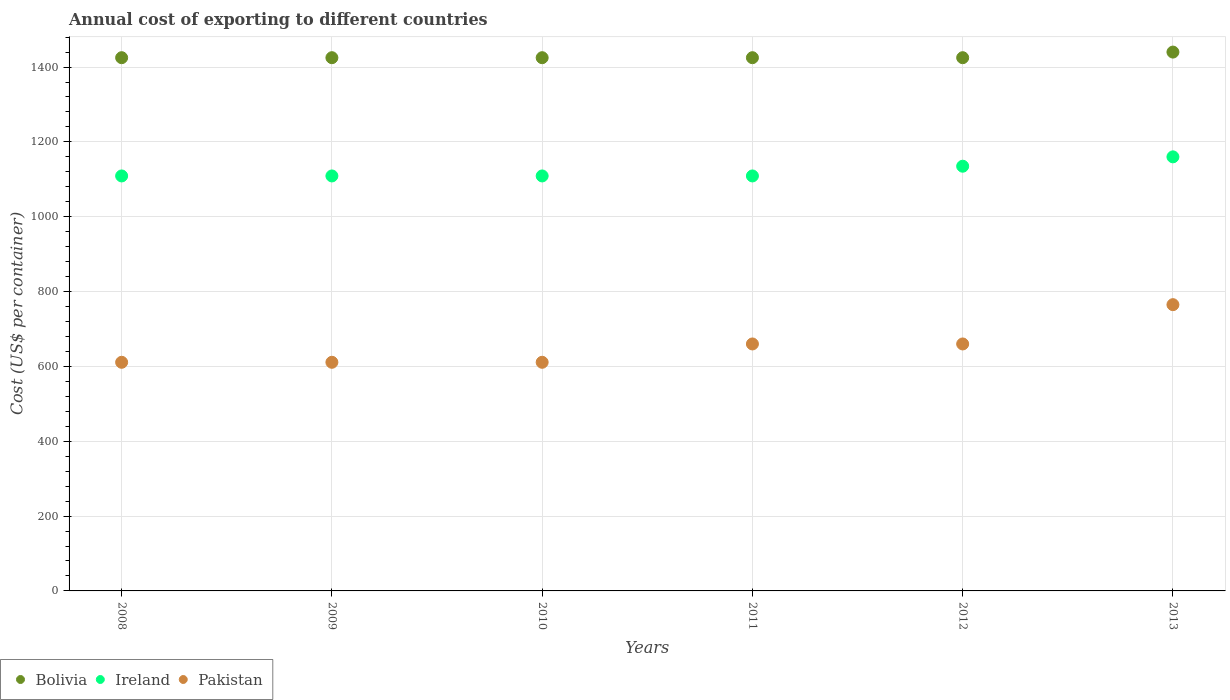What is the total annual cost of exporting in Bolivia in 2013?
Make the answer very short. 1440. Across all years, what is the maximum total annual cost of exporting in Pakistan?
Give a very brief answer. 765. Across all years, what is the minimum total annual cost of exporting in Pakistan?
Give a very brief answer. 611. In which year was the total annual cost of exporting in Pakistan maximum?
Keep it short and to the point. 2013. What is the total total annual cost of exporting in Bolivia in the graph?
Provide a succinct answer. 8565. What is the difference between the total annual cost of exporting in Ireland in 2010 and that in 2012?
Your response must be concise. -26. What is the difference between the total annual cost of exporting in Bolivia in 2013 and the total annual cost of exporting in Pakistan in 2012?
Give a very brief answer. 780. What is the average total annual cost of exporting in Bolivia per year?
Provide a short and direct response. 1427.5. In the year 2008, what is the difference between the total annual cost of exporting in Ireland and total annual cost of exporting in Bolivia?
Provide a short and direct response. -316. In how many years, is the total annual cost of exporting in Bolivia greater than 880 US$?
Provide a succinct answer. 6. What is the ratio of the total annual cost of exporting in Ireland in 2008 to that in 2010?
Keep it short and to the point. 1. What is the difference between the highest and the second highest total annual cost of exporting in Pakistan?
Make the answer very short. 105. What is the difference between the highest and the lowest total annual cost of exporting in Pakistan?
Provide a succinct answer. 154. In how many years, is the total annual cost of exporting in Ireland greater than the average total annual cost of exporting in Ireland taken over all years?
Provide a short and direct response. 2. Is the sum of the total annual cost of exporting in Pakistan in 2010 and 2011 greater than the maximum total annual cost of exporting in Ireland across all years?
Provide a short and direct response. Yes. Does the total annual cost of exporting in Pakistan monotonically increase over the years?
Make the answer very short. No. Is the total annual cost of exporting in Ireland strictly less than the total annual cost of exporting in Pakistan over the years?
Your answer should be compact. No. How many years are there in the graph?
Give a very brief answer. 6. Does the graph contain grids?
Give a very brief answer. Yes. Where does the legend appear in the graph?
Ensure brevity in your answer.  Bottom left. How many legend labels are there?
Offer a very short reply. 3. How are the legend labels stacked?
Ensure brevity in your answer.  Horizontal. What is the title of the graph?
Provide a succinct answer. Annual cost of exporting to different countries. What is the label or title of the Y-axis?
Offer a very short reply. Cost (US$ per container). What is the Cost (US$ per container) in Bolivia in 2008?
Provide a succinct answer. 1425. What is the Cost (US$ per container) in Ireland in 2008?
Provide a succinct answer. 1109. What is the Cost (US$ per container) of Pakistan in 2008?
Keep it short and to the point. 611. What is the Cost (US$ per container) of Bolivia in 2009?
Give a very brief answer. 1425. What is the Cost (US$ per container) in Ireland in 2009?
Offer a very short reply. 1109. What is the Cost (US$ per container) in Pakistan in 2009?
Give a very brief answer. 611. What is the Cost (US$ per container) in Bolivia in 2010?
Your answer should be compact. 1425. What is the Cost (US$ per container) of Ireland in 2010?
Your answer should be very brief. 1109. What is the Cost (US$ per container) of Pakistan in 2010?
Your answer should be compact. 611. What is the Cost (US$ per container) in Bolivia in 2011?
Your response must be concise. 1425. What is the Cost (US$ per container) in Ireland in 2011?
Offer a very short reply. 1109. What is the Cost (US$ per container) of Pakistan in 2011?
Your answer should be compact. 660. What is the Cost (US$ per container) of Bolivia in 2012?
Keep it short and to the point. 1425. What is the Cost (US$ per container) in Ireland in 2012?
Your response must be concise. 1135. What is the Cost (US$ per container) in Pakistan in 2012?
Make the answer very short. 660. What is the Cost (US$ per container) in Bolivia in 2013?
Offer a terse response. 1440. What is the Cost (US$ per container) in Ireland in 2013?
Your response must be concise. 1160. What is the Cost (US$ per container) in Pakistan in 2013?
Your response must be concise. 765. Across all years, what is the maximum Cost (US$ per container) in Bolivia?
Your answer should be very brief. 1440. Across all years, what is the maximum Cost (US$ per container) in Ireland?
Your answer should be very brief. 1160. Across all years, what is the maximum Cost (US$ per container) of Pakistan?
Your answer should be compact. 765. Across all years, what is the minimum Cost (US$ per container) in Bolivia?
Your response must be concise. 1425. Across all years, what is the minimum Cost (US$ per container) in Ireland?
Give a very brief answer. 1109. Across all years, what is the minimum Cost (US$ per container) of Pakistan?
Give a very brief answer. 611. What is the total Cost (US$ per container) in Bolivia in the graph?
Your answer should be very brief. 8565. What is the total Cost (US$ per container) in Ireland in the graph?
Your answer should be very brief. 6731. What is the total Cost (US$ per container) in Pakistan in the graph?
Your answer should be compact. 3918. What is the difference between the Cost (US$ per container) of Bolivia in 2008 and that in 2009?
Your response must be concise. 0. What is the difference between the Cost (US$ per container) in Ireland in 2008 and that in 2009?
Your answer should be compact. 0. What is the difference between the Cost (US$ per container) of Ireland in 2008 and that in 2010?
Give a very brief answer. 0. What is the difference between the Cost (US$ per container) in Pakistan in 2008 and that in 2010?
Your answer should be very brief. 0. What is the difference between the Cost (US$ per container) in Bolivia in 2008 and that in 2011?
Make the answer very short. 0. What is the difference between the Cost (US$ per container) in Ireland in 2008 and that in 2011?
Your answer should be compact. 0. What is the difference between the Cost (US$ per container) of Pakistan in 2008 and that in 2011?
Keep it short and to the point. -49. What is the difference between the Cost (US$ per container) in Bolivia in 2008 and that in 2012?
Make the answer very short. 0. What is the difference between the Cost (US$ per container) in Pakistan in 2008 and that in 2012?
Give a very brief answer. -49. What is the difference between the Cost (US$ per container) of Bolivia in 2008 and that in 2013?
Give a very brief answer. -15. What is the difference between the Cost (US$ per container) in Ireland in 2008 and that in 2013?
Provide a succinct answer. -51. What is the difference between the Cost (US$ per container) in Pakistan in 2008 and that in 2013?
Make the answer very short. -154. What is the difference between the Cost (US$ per container) in Bolivia in 2009 and that in 2010?
Offer a terse response. 0. What is the difference between the Cost (US$ per container) of Ireland in 2009 and that in 2010?
Keep it short and to the point. 0. What is the difference between the Cost (US$ per container) of Pakistan in 2009 and that in 2010?
Your response must be concise. 0. What is the difference between the Cost (US$ per container) in Bolivia in 2009 and that in 2011?
Your response must be concise. 0. What is the difference between the Cost (US$ per container) in Pakistan in 2009 and that in 2011?
Offer a very short reply. -49. What is the difference between the Cost (US$ per container) of Ireland in 2009 and that in 2012?
Offer a very short reply. -26. What is the difference between the Cost (US$ per container) of Pakistan in 2009 and that in 2012?
Provide a succinct answer. -49. What is the difference between the Cost (US$ per container) in Bolivia in 2009 and that in 2013?
Offer a terse response. -15. What is the difference between the Cost (US$ per container) of Ireland in 2009 and that in 2013?
Give a very brief answer. -51. What is the difference between the Cost (US$ per container) of Pakistan in 2009 and that in 2013?
Give a very brief answer. -154. What is the difference between the Cost (US$ per container) in Bolivia in 2010 and that in 2011?
Ensure brevity in your answer.  0. What is the difference between the Cost (US$ per container) in Pakistan in 2010 and that in 2011?
Keep it short and to the point. -49. What is the difference between the Cost (US$ per container) of Ireland in 2010 and that in 2012?
Provide a succinct answer. -26. What is the difference between the Cost (US$ per container) of Pakistan in 2010 and that in 2012?
Your answer should be very brief. -49. What is the difference between the Cost (US$ per container) of Ireland in 2010 and that in 2013?
Provide a short and direct response. -51. What is the difference between the Cost (US$ per container) of Pakistan in 2010 and that in 2013?
Offer a terse response. -154. What is the difference between the Cost (US$ per container) of Bolivia in 2011 and that in 2012?
Offer a very short reply. 0. What is the difference between the Cost (US$ per container) of Ireland in 2011 and that in 2012?
Your response must be concise. -26. What is the difference between the Cost (US$ per container) of Ireland in 2011 and that in 2013?
Make the answer very short. -51. What is the difference between the Cost (US$ per container) of Pakistan in 2011 and that in 2013?
Make the answer very short. -105. What is the difference between the Cost (US$ per container) of Bolivia in 2012 and that in 2013?
Provide a short and direct response. -15. What is the difference between the Cost (US$ per container) in Ireland in 2012 and that in 2013?
Keep it short and to the point. -25. What is the difference between the Cost (US$ per container) in Pakistan in 2012 and that in 2013?
Your answer should be very brief. -105. What is the difference between the Cost (US$ per container) of Bolivia in 2008 and the Cost (US$ per container) of Ireland in 2009?
Provide a succinct answer. 316. What is the difference between the Cost (US$ per container) in Bolivia in 2008 and the Cost (US$ per container) in Pakistan in 2009?
Your response must be concise. 814. What is the difference between the Cost (US$ per container) of Ireland in 2008 and the Cost (US$ per container) of Pakistan in 2009?
Your response must be concise. 498. What is the difference between the Cost (US$ per container) of Bolivia in 2008 and the Cost (US$ per container) of Ireland in 2010?
Give a very brief answer. 316. What is the difference between the Cost (US$ per container) in Bolivia in 2008 and the Cost (US$ per container) in Pakistan in 2010?
Keep it short and to the point. 814. What is the difference between the Cost (US$ per container) of Ireland in 2008 and the Cost (US$ per container) of Pakistan in 2010?
Make the answer very short. 498. What is the difference between the Cost (US$ per container) of Bolivia in 2008 and the Cost (US$ per container) of Ireland in 2011?
Provide a short and direct response. 316. What is the difference between the Cost (US$ per container) in Bolivia in 2008 and the Cost (US$ per container) in Pakistan in 2011?
Your response must be concise. 765. What is the difference between the Cost (US$ per container) in Ireland in 2008 and the Cost (US$ per container) in Pakistan in 2011?
Your answer should be very brief. 449. What is the difference between the Cost (US$ per container) in Bolivia in 2008 and the Cost (US$ per container) in Ireland in 2012?
Offer a terse response. 290. What is the difference between the Cost (US$ per container) of Bolivia in 2008 and the Cost (US$ per container) of Pakistan in 2012?
Your answer should be compact. 765. What is the difference between the Cost (US$ per container) of Ireland in 2008 and the Cost (US$ per container) of Pakistan in 2012?
Give a very brief answer. 449. What is the difference between the Cost (US$ per container) in Bolivia in 2008 and the Cost (US$ per container) in Ireland in 2013?
Your response must be concise. 265. What is the difference between the Cost (US$ per container) in Bolivia in 2008 and the Cost (US$ per container) in Pakistan in 2013?
Ensure brevity in your answer.  660. What is the difference between the Cost (US$ per container) of Ireland in 2008 and the Cost (US$ per container) of Pakistan in 2013?
Provide a short and direct response. 344. What is the difference between the Cost (US$ per container) of Bolivia in 2009 and the Cost (US$ per container) of Ireland in 2010?
Give a very brief answer. 316. What is the difference between the Cost (US$ per container) of Bolivia in 2009 and the Cost (US$ per container) of Pakistan in 2010?
Your answer should be very brief. 814. What is the difference between the Cost (US$ per container) of Ireland in 2009 and the Cost (US$ per container) of Pakistan in 2010?
Give a very brief answer. 498. What is the difference between the Cost (US$ per container) in Bolivia in 2009 and the Cost (US$ per container) in Ireland in 2011?
Provide a succinct answer. 316. What is the difference between the Cost (US$ per container) in Bolivia in 2009 and the Cost (US$ per container) in Pakistan in 2011?
Provide a succinct answer. 765. What is the difference between the Cost (US$ per container) of Ireland in 2009 and the Cost (US$ per container) of Pakistan in 2011?
Your answer should be very brief. 449. What is the difference between the Cost (US$ per container) in Bolivia in 2009 and the Cost (US$ per container) in Ireland in 2012?
Provide a succinct answer. 290. What is the difference between the Cost (US$ per container) of Bolivia in 2009 and the Cost (US$ per container) of Pakistan in 2012?
Give a very brief answer. 765. What is the difference between the Cost (US$ per container) of Ireland in 2009 and the Cost (US$ per container) of Pakistan in 2012?
Provide a succinct answer. 449. What is the difference between the Cost (US$ per container) of Bolivia in 2009 and the Cost (US$ per container) of Ireland in 2013?
Offer a very short reply. 265. What is the difference between the Cost (US$ per container) of Bolivia in 2009 and the Cost (US$ per container) of Pakistan in 2013?
Offer a terse response. 660. What is the difference between the Cost (US$ per container) of Ireland in 2009 and the Cost (US$ per container) of Pakistan in 2013?
Offer a very short reply. 344. What is the difference between the Cost (US$ per container) of Bolivia in 2010 and the Cost (US$ per container) of Ireland in 2011?
Offer a terse response. 316. What is the difference between the Cost (US$ per container) in Bolivia in 2010 and the Cost (US$ per container) in Pakistan in 2011?
Your answer should be very brief. 765. What is the difference between the Cost (US$ per container) in Ireland in 2010 and the Cost (US$ per container) in Pakistan in 2011?
Give a very brief answer. 449. What is the difference between the Cost (US$ per container) in Bolivia in 2010 and the Cost (US$ per container) in Ireland in 2012?
Provide a succinct answer. 290. What is the difference between the Cost (US$ per container) of Bolivia in 2010 and the Cost (US$ per container) of Pakistan in 2012?
Provide a succinct answer. 765. What is the difference between the Cost (US$ per container) in Ireland in 2010 and the Cost (US$ per container) in Pakistan in 2012?
Your answer should be very brief. 449. What is the difference between the Cost (US$ per container) in Bolivia in 2010 and the Cost (US$ per container) in Ireland in 2013?
Your answer should be very brief. 265. What is the difference between the Cost (US$ per container) of Bolivia in 2010 and the Cost (US$ per container) of Pakistan in 2013?
Offer a very short reply. 660. What is the difference between the Cost (US$ per container) of Ireland in 2010 and the Cost (US$ per container) of Pakistan in 2013?
Your answer should be very brief. 344. What is the difference between the Cost (US$ per container) in Bolivia in 2011 and the Cost (US$ per container) in Ireland in 2012?
Your response must be concise. 290. What is the difference between the Cost (US$ per container) of Bolivia in 2011 and the Cost (US$ per container) of Pakistan in 2012?
Offer a terse response. 765. What is the difference between the Cost (US$ per container) in Ireland in 2011 and the Cost (US$ per container) in Pakistan in 2012?
Offer a terse response. 449. What is the difference between the Cost (US$ per container) of Bolivia in 2011 and the Cost (US$ per container) of Ireland in 2013?
Provide a short and direct response. 265. What is the difference between the Cost (US$ per container) of Bolivia in 2011 and the Cost (US$ per container) of Pakistan in 2013?
Your response must be concise. 660. What is the difference between the Cost (US$ per container) of Ireland in 2011 and the Cost (US$ per container) of Pakistan in 2013?
Your answer should be compact. 344. What is the difference between the Cost (US$ per container) of Bolivia in 2012 and the Cost (US$ per container) of Ireland in 2013?
Provide a succinct answer. 265. What is the difference between the Cost (US$ per container) in Bolivia in 2012 and the Cost (US$ per container) in Pakistan in 2013?
Offer a very short reply. 660. What is the difference between the Cost (US$ per container) in Ireland in 2012 and the Cost (US$ per container) in Pakistan in 2013?
Your answer should be very brief. 370. What is the average Cost (US$ per container) in Bolivia per year?
Offer a terse response. 1427.5. What is the average Cost (US$ per container) in Ireland per year?
Provide a short and direct response. 1121.83. What is the average Cost (US$ per container) in Pakistan per year?
Make the answer very short. 653. In the year 2008, what is the difference between the Cost (US$ per container) in Bolivia and Cost (US$ per container) in Ireland?
Provide a succinct answer. 316. In the year 2008, what is the difference between the Cost (US$ per container) of Bolivia and Cost (US$ per container) of Pakistan?
Make the answer very short. 814. In the year 2008, what is the difference between the Cost (US$ per container) in Ireland and Cost (US$ per container) in Pakistan?
Provide a succinct answer. 498. In the year 2009, what is the difference between the Cost (US$ per container) in Bolivia and Cost (US$ per container) in Ireland?
Keep it short and to the point. 316. In the year 2009, what is the difference between the Cost (US$ per container) in Bolivia and Cost (US$ per container) in Pakistan?
Your answer should be very brief. 814. In the year 2009, what is the difference between the Cost (US$ per container) of Ireland and Cost (US$ per container) of Pakistan?
Provide a short and direct response. 498. In the year 2010, what is the difference between the Cost (US$ per container) in Bolivia and Cost (US$ per container) in Ireland?
Your answer should be compact. 316. In the year 2010, what is the difference between the Cost (US$ per container) of Bolivia and Cost (US$ per container) of Pakistan?
Your answer should be very brief. 814. In the year 2010, what is the difference between the Cost (US$ per container) in Ireland and Cost (US$ per container) in Pakistan?
Give a very brief answer. 498. In the year 2011, what is the difference between the Cost (US$ per container) in Bolivia and Cost (US$ per container) in Ireland?
Offer a very short reply. 316. In the year 2011, what is the difference between the Cost (US$ per container) in Bolivia and Cost (US$ per container) in Pakistan?
Make the answer very short. 765. In the year 2011, what is the difference between the Cost (US$ per container) of Ireland and Cost (US$ per container) of Pakistan?
Your answer should be compact. 449. In the year 2012, what is the difference between the Cost (US$ per container) in Bolivia and Cost (US$ per container) in Ireland?
Offer a very short reply. 290. In the year 2012, what is the difference between the Cost (US$ per container) in Bolivia and Cost (US$ per container) in Pakistan?
Keep it short and to the point. 765. In the year 2012, what is the difference between the Cost (US$ per container) in Ireland and Cost (US$ per container) in Pakistan?
Make the answer very short. 475. In the year 2013, what is the difference between the Cost (US$ per container) in Bolivia and Cost (US$ per container) in Ireland?
Offer a terse response. 280. In the year 2013, what is the difference between the Cost (US$ per container) of Bolivia and Cost (US$ per container) of Pakistan?
Ensure brevity in your answer.  675. In the year 2013, what is the difference between the Cost (US$ per container) in Ireland and Cost (US$ per container) in Pakistan?
Offer a terse response. 395. What is the ratio of the Cost (US$ per container) in Ireland in 2008 to that in 2009?
Offer a terse response. 1. What is the ratio of the Cost (US$ per container) of Pakistan in 2008 to that in 2009?
Your answer should be very brief. 1. What is the ratio of the Cost (US$ per container) of Ireland in 2008 to that in 2010?
Offer a very short reply. 1. What is the ratio of the Cost (US$ per container) in Pakistan in 2008 to that in 2010?
Offer a very short reply. 1. What is the ratio of the Cost (US$ per container) in Ireland in 2008 to that in 2011?
Provide a succinct answer. 1. What is the ratio of the Cost (US$ per container) in Pakistan in 2008 to that in 2011?
Keep it short and to the point. 0.93. What is the ratio of the Cost (US$ per container) in Ireland in 2008 to that in 2012?
Offer a very short reply. 0.98. What is the ratio of the Cost (US$ per container) of Pakistan in 2008 to that in 2012?
Your answer should be very brief. 0.93. What is the ratio of the Cost (US$ per container) in Bolivia in 2008 to that in 2013?
Provide a succinct answer. 0.99. What is the ratio of the Cost (US$ per container) in Ireland in 2008 to that in 2013?
Your response must be concise. 0.96. What is the ratio of the Cost (US$ per container) in Pakistan in 2008 to that in 2013?
Provide a succinct answer. 0.8. What is the ratio of the Cost (US$ per container) in Ireland in 2009 to that in 2011?
Offer a terse response. 1. What is the ratio of the Cost (US$ per container) of Pakistan in 2009 to that in 2011?
Make the answer very short. 0.93. What is the ratio of the Cost (US$ per container) in Bolivia in 2009 to that in 2012?
Ensure brevity in your answer.  1. What is the ratio of the Cost (US$ per container) in Ireland in 2009 to that in 2012?
Make the answer very short. 0.98. What is the ratio of the Cost (US$ per container) of Pakistan in 2009 to that in 2012?
Keep it short and to the point. 0.93. What is the ratio of the Cost (US$ per container) in Ireland in 2009 to that in 2013?
Offer a terse response. 0.96. What is the ratio of the Cost (US$ per container) in Pakistan in 2009 to that in 2013?
Offer a terse response. 0.8. What is the ratio of the Cost (US$ per container) in Ireland in 2010 to that in 2011?
Make the answer very short. 1. What is the ratio of the Cost (US$ per container) of Pakistan in 2010 to that in 2011?
Give a very brief answer. 0.93. What is the ratio of the Cost (US$ per container) in Ireland in 2010 to that in 2012?
Provide a succinct answer. 0.98. What is the ratio of the Cost (US$ per container) of Pakistan in 2010 to that in 2012?
Provide a short and direct response. 0.93. What is the ratio of the Cost (US$ per container) in Bolivia in 2010 to that in 2013?
Make the answer very short. 0.99. What is the ratio of the Cost (US$ per container) in Ireland in 2010 to that in 2013?
Keep it short and to the point. 0.96. What is the ratio of the Cost (US$ per container) of Pakistan in 2010 to that in 2013?
Provide a short and direct response. 0.8. What is the ratio of the Cost (US$ per container) in Bolivia in 2011 to that in 2012?
Offer a terse response. 1. What is the ratio of the Cost (US$ per container) in Ireland in 2011 to that in 2012?
Ensure brevity in your answer.  0.98. What is the ratio of the Cost (US$ per container) of Pakistan in 2011 to that in 2012?
Your answer should be compact. 1. What is the ratio of the Cost (US$ per container) of Ireland in 2011 to that in 2013?
Your answer should be very brief. 0.96. What is the ratio of the Cost (US$ per container) in Pakistan in 2011 to that in 2013?
Ensure brevity in your answer.  0.86. What is the ratio of the Cost (US$ per container) of Ireland in 2012 to that in 2013?
Your response must be concise. 0.98. What is the ratio of the Cost (US$ per container) in Pakistan in 2012 to that in 2013?
Your answer should be compact. 0.86. What is the difference between the highest and the second highest Cost (US$ per container) in Pakistan?
Provide a succinct answer. 105. What is the difference between the highest and the lowest Cost (US$ per container) in Bolivia?
Your answer should be compact. 15. What is the difference between the highest and the lowest Cost (US$ per container) of Ireland?
Make the answer very short. 51. What is the difference between the highest and the lowest Cost (US$ per container) of Pakistan?
Ensure brevity in your answer.  154. 